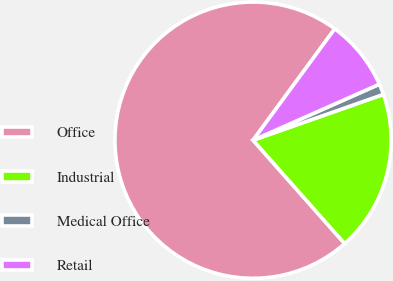Convert chart. <chart><loc_0><loc_0><loc_500><loc_500><pie_chart><fcel>Office<fcel>Industrial<fcel>Medical Office<fcel>Retail<nl><fcel>71.61%<fcel>18.84%<fcel>1.26%<fcel>8.29%<nl></chart> 